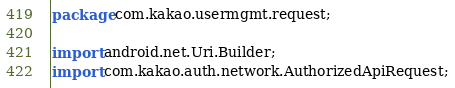<code> <loc_0><loc_0><loc_500><loc_500><_Java_>package com.kakao.usermgmt.request;

import android.net.Uri.Builder;
import com.kakao.auth.network.AuthorizedApiRequest;</code> 